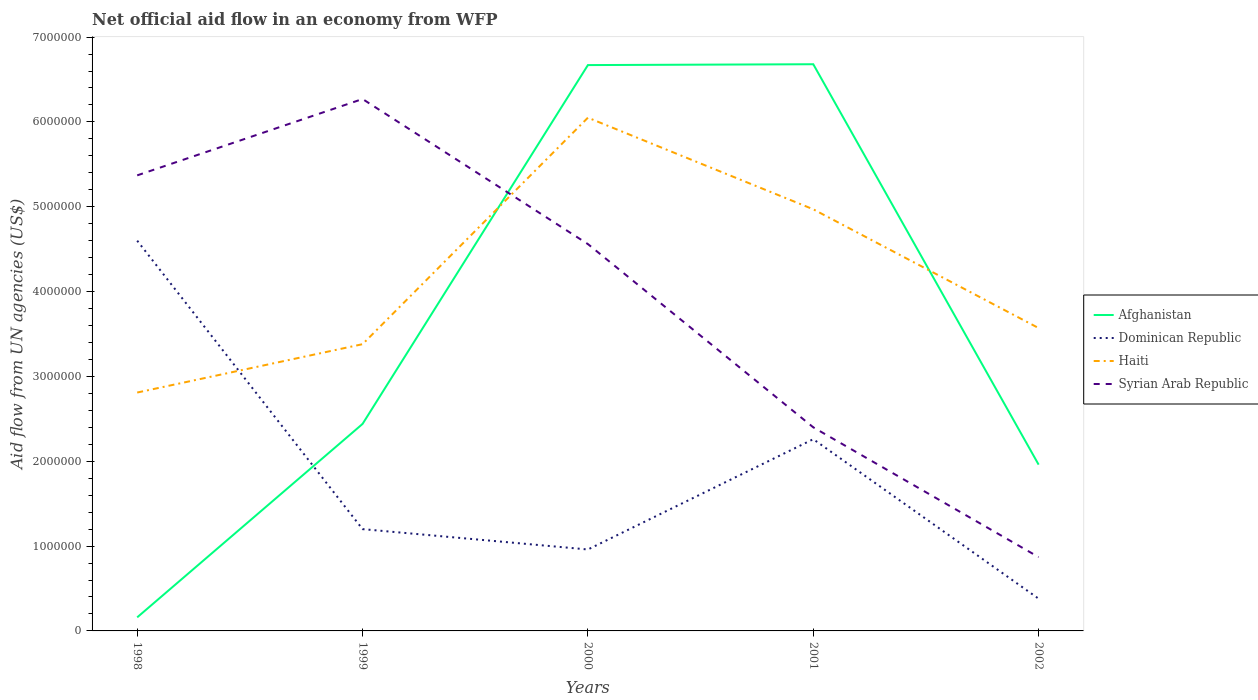How many different coloured lines are there?
Provide a succinct answer. 4. Does the line corresponding to Syrian Arab Republic intersect with the line corresponding to Afghanistan?
Provide a succinct answer. Yes. Across all years, what is the maximum net official aid flow in Dominican Republic?
Your answer should be very brief. 3.80e+05. In which year was the net official aid flow in Syrian Arab Republic maximum?
Your answer should be compact. 2002. What is the total net official aid flow in Dominican Republic in the graph?
Keep it short and to the point. 5.80e+05. What is the difference between the highest and the second highest net official aid flow in Afghanistan?
Your answer should be very brief. 6.52e+06. How many years are there in the graph?
Make the answer very short. 5. Are the values on the major ticks of Y-axis written in scientific E-notation?
Make the answer very short. No. Does the graph contain any zero values?
Your response must be concise. No. How many legend labels are there?
Provide a succinct answer. 4. How are the legend labels stacked?
Your answer should be compact. Vertical. What is the title of the graph?
Ensure brevity in your answer.  Net official aid flow in an economy from WFP. Does "Benin" appear as one of the legend labels in the graph?
Your answer should be very brief. No. What is the label or title of the X-axis?
Your answer should be very brief. Years. What is the label or title of the Y-axis?
Provide a succinct answer. Aid flow from UN agencies (US$). What is the Aid flow from UN agencies (US$) in Dominican Republic in 1998?
Ensure brevity in your answer.  4.60e+06. What is the Aid flow from UN agencies (US$) of Haiti in 1998?
Your response must be concise. 2.81e+06. What is the Aid flow from UN agencies (US$) of Syrian Arab Republic in 1998?
Provide a succinct answer. 5.37e+06. What is the Aid flow from UN agencies (US$) of Afghanistan in 1999?
Provide a succinct answer. 2.44e+06. What is the Aid flow from UN agencies (US$) of Dominican Republic in 1999?
Your response must be concise. 1.20e+06. What is the Aid flow from UN agencies (US$) in Haiti in 1999?
Provide a short and direct response. 3.38e+06. What is the Aid flow from UN agencies (US$) of Syrian Arab Republic in 1999?
Make the answer very short. 6.27e+06. What is the Aid flow from UN agencies (US$) in Afghanistan in 2000?
Your answer should be very brief. 6.67e+06. What is the Aid flow from UN agencies (US$) in Dominican Republic in 2000?
Keep it short and to the point. 9.60e+05. What is the Aid flow from UN agencies (US$) in Haiti in 2000?
Your answer should be compact. 6.05e+06. What is the Aid flow from UN agencies (US$) of Syrian Arab Republic in 2000?
Offer a terse response. 4.56e+06. What is the Aid flow from UN agencies (US$) in Afghanistan in 2001?
Your response must be concise. 6.68e+06. What is the Aid flow from UN agencies (US$) in Dominican Republic in 2001?
Provide a short and direct response. 2.26e+06. What is the Aid flow from UN agencies (US$) in Haiti in 2001?
Give a very brief answer. 4.97e+06. What is the Aid flow from UN agencies (US$) of Syrian Arab Republic in 2001?
Ensure brevity in your answer.  2.40e+06. What is the Aid flow from UN agencies (US$) in Afghanistan in 2002?
Provide a short and direct response. 1.96e+06. What is the Aid flow from UN agencies (US$) in Dominican Republic in 2002?
Ensure brevity in your answer.  3.80e+05. What is the Aid flow from UN agencies (US$) of Haiti in 2002?
Provide a short and direct response. 3.57e+06. What is the Aid flow from UN agencies (US$) in Syrian Arab Republic in 2002?
Offer a terse response. 8.70e+05. Across all years, what is the maximum Aid flow from UN agencies (US$) of Afghanistan?
Give a very brief answer. 6.68e+06. Across all years, what is the maximum Aid flow from UN agencies (US$) in Dominican Republic?
Provide a succinct answer. 4.60e+06. Across all years, what is the maximum Aid flow from UN agencies (US$) of Haiti?
Give a very brief answer. 6.05e+06. Across all years, what is the maximum Aid flow from UN agencies (US$) of Syrian Arab Republic?
Ensure brevity in your answer.  6.27e+06. Across all years, what is the minimum Aid flow from UN agencies (US$) of Dominican Republic?
Give a very brief answer. 3.80e+05. Across all years, what is the minimum Aid flow from UN agencies (US$) of Haiti?
Your response must be concise. 2.81e+06. Across all years, what is the minimum Aid flow from UN agencies (US$) of Syrian Arab Republic?
Your response must be concise. 8.70e+05. What is the total Aid flow from UN agencies (US$) of Afghanistan in the graph?
Your answer should be compact. 1.79e+07. What is the total Aid flow from UN agencies (US$) in Dominican Republic in the graph?
Provide a short and direct response. 9.40e+06. What is the total Aid flow from UN agencies (US$) in Haiti in the graph?
Give a very brief answer. 2.08e+07. What is the total Aid flow from UN agencies (US$) of Syrian Arab Republic in the graph?
Keep it short and to the point. 1.95e+07. What is the difference between the Aid flow from UN agencies (US$) of Afghanistan in 1998 and that in 1999?
Provide a short and direct response. -2.28e+06. What is the difference between the Aid flow from UN agencies (US$) of Dominican Republic in 1998 and that in 1999?
Ensure brevity in your answer.  3.40e+06. What is the difference between the Aid flow from UN agencies (US$) of Haiti in 1998 and that in 1999?
Your answer should be compact. -5.70e+05. What is the difference between the Aid flow from UN agencies (US$) of Syrian Arab Republic in 1998 and that in 1999?
Offer a very short reply. -9.00e+05. What is the difference between the Aid flow from UN agencies (US$) of Afghanistan in 1998 and that in 2000?
Your response must be concise. -6.51e+06. What is the difference between the Aid flow from UN agencies (US$) in Dominican Republic in 1998 and that in 2000?
Your answer should be compact. 3.64e+06. What is the difference between the Aid flow from UN agencies (US$) of Haiti in 1998 and that in 2000?
Your answer should be very brief. -3.24e+06. What is the difference between the Aid flow from UN agencies (US$) in Syrian Arab Republic in 1998 and that in 2000?
Keep it short and to the point. 8.10e+05. What is the difference between the Aid flow from UN agencies (US$) in Afghanistan in 1998 and that in 2001?
Provide a succinct answer. -6.52e+06. What is the difference between the Aid flow from UN agencies (US$) of Dominican Republic in 1998 and that in 2001?
Give a very brief answer. 2.34e+06. What is the difference between the Aid flow from UN agencies (US$) in Haiti in 1998 and that in 2001?
Your answer should be very brief. -2.16e+06. What is the difference between the Aid flow from UN agencies (US$) in Syrian Arab Republic in 1998 and that in 2001?
Your answer should be compact. 2.97e+06. What is the difference between the Aid flow from UN agencies (US$) in Afghanistan in 1998 and that in 2002?
Your response must be concise. -1.80e+06. What is the difference between the Aid flow from UN agencies (US$) in Dominican Republic in 1998 and that in 2002?
Provide a short and direct response. 4.22e+06. What is the difference between the Aid flow from UN agencies (US$) of Haiti in 1998 and that in 2002?
Give a very brief answer. -7.60e+05. What is the difference between the Aid flow from UN agencies (US$) of Syrian Arab Republic in 1998 and that in 2002?
Ensure brevity in your answer.  4.50e+06. What is the difference between the Aid flow from UN agencies (US$) of Afghanistan in 1999 and that in 2000?
Make the answer very short. -4.23e+06. What is the difference between the Aid flow from UN agencies (US$) of Haiti in 1999 and that in 2000?
Your answer should be compact. -2.67e+06. What is the difference between the Aid flow from UN agencies (US$) of Syrian Arab Republic in 1999 and that in 2000?
Make the answer very short. 1.71e+06. What is the difference between the Aid flow from UN agencies (US$) of Afghanistan in 1999 and that in 2001?
Your answer should be very brief. -4.24e+06. What is the difference between the Aid flow from UN agencies (US$) of Dominican Republic in 1999 and that in 2001?
Your response must be concise. -1.06e+06. What is the difference between the Aid flow from UN agencies (US$) in Haiti in 1999 and that in 2001?
Your answer should be compact. -1.59e+06. What is the difference between the Aid flow from UN agencies (US$) of Syrian Arab Republic in 1999 and that in 2001?
Keep it short and to the point. 3.87e+06. What is the difference between the Aid flow from UN agencies (US$) of Afghanistan in 1999 and that in 2002?
Provide a short and direct response. 4.80e+05. What is the difference between the Aid flow from UN agencies (US$) in Dominican Republic in 1999 and that in 2002?
Ensure brevity in your answer.  8.20e+05. What is the difference between the Aid flow from UN agencies (US$) in Syrian Arab Republic in 1999 and that in 2002?
Give a very brief answer. 5.40e+06. What is the difference between the Aid flow from UN agencies (US$) in Dominican Republic in 2000 and that in 2001?
Provide a short and direct response. -1.30e+06. What is the difference between the Aid flow from UN agencies (US$) of Haiti in 2000 and that in 2001?
Ensure brevity in your answer.  1.08e+06. What is the difference between the Aid flow from UN agencies (US$) in Syrian Arab Republic in 2000 and that in 2001?
Give a very brief answer. 2.16e+06. What is the difference between the Aid flow from UN agencies (US$) of Afghanistan in 2000 and that in 2002?
Your response must be concise. 4.71e+06. What is the difference between the Aid flow from UN agencies (US$) in Dominican Republic in 2000 and that in 2002?
Provide a succinct answer. 5.80e+05. What is the difference between the Aid flow from UN agencies (US$) of Haiti in 2000 and that in 2002?
Your response must be concise. 2.48e+06. What is the difference between the Aid flow from UN agencies (US$) of Syrian Arab Republic in 2000 and that in 2002?
Make the answer very short. 3.69e+06. What is the difference between the Aid flow from UN agencies (US$) of Afghanistan in 2001 and that in 2002?
Give a very brief answer. 4.72e+06. What is the difference between the Aid flow from UN agencies (US$) of Dominican Republic in 2001 and that in 2002?
Offer a terse response. 1.88e+06. What is the difference between the Aid flow from UN agencies (US$) of Haiti in 2001 and that in 2002?
Your answer should be very brief. 1.40e+06. What is the difference between the Aid flow from UN agencies (US$) in Syrian Arab Republic in 2001 and that in 2002?
Your answer should be very brief. 1.53e+06. What is the difference between the Aid flow from UN agencies (US$) in Afghanistan in 1998 and the Aid flow from UN agencies (US$) in Dominican Republic in 1999?
Your answer should be very brief. -1.04e+06. What is the difference between the Aid flow from UN agencies (US$) of Afghanistan in 1998 and the Aid flow from UN agencies (US$) of Haiti in 1999?
Provide a succinct answer. -3.22e+06. What is the difference between the Aid flow from UN agencies (US$) of Afghanistan in 1998 and the Aid flow from UN agencies (US$) of Syrian Arab Republic in 1999?
Give a very brief answer. -6.11e+06. What is the difference between the Aid flow from UN agencies (US$) of Dominican Republic in 1998 and the Aid flow from UN agencies (US$) of Haiti in 1999?
Offer a terse response. 1.22e+06. What is the difference between the Aid flow from UN agencies (US$) in Dominican Republic in 1998 and the Aid flow from UN agencies (US$) in Syrian Arab Republic in 1999?
Give a very brief answer. -1.67e+06. What is the difference between the Aid flow from UN agencies (US$) of Haiti in 1998 and the Aid flow from UN agencies (US$) of Syrian Arab Republic in 1999?
Your answer should be compact. -3.46e+06. What is the difference between the Aid flow from UN agencies (US$) in Afghanistan in 1998 and the Aid flow from UN agencies (US$) in Dominican Republic in 2000?
Give a very brief answer. -8.00e+05. What is the difference between the Aid flow from UN agencies (US$) in Afghanistan in 1998 and the Aid flow from UN agencies (US$) in Haiti in 2000?
Provide a short and direct response. -5.89e+06. What is the difference between the Aid flow from UN agencies (US$) of Afghanistan in 1998 and the Aid flow from UN agencies (US$) of Syrian Arab Republic in 2000?
Offer a terse response. -4.40e+06. What is the difference between the Aid flow from UN agencies (US$) in Dominican Republic in 1998 and the Aid flow from UN agencies (US$) in Haiti in 2000?
Ensure brevity in your answer.  -1.45e+06. What is the difference between the Aid flow from UN agencies (US$) of Haiti in 1998 and the Aid flow from UN agencies (US$) of Syrian Arab Republic in 2000?
Offer a terse response. -1.75e+06. What is the difference between the Aid flow from UN agencies (US$) in Afghanistan in 1998 and the Aid flow from UN agencies (US$) in Dominican Republic in 2001?
Provide a succinct answer. -2.10e+06. What is the difference between the Aid flow from UN agencies (US$) of Afghanistan in 1998 and the Aid flow from UN agencies (US$) of Haiti in 2001?
Ensure brevity in your answer.  -4.81e+06. What is the difference between the Aid flow from UN agencies (US$) in Afghanistan in 1998 and the Aid flow from UN agencies (US$) in Syrian Arab Republic in 2001?
Offer a terse response. -2.24e+06. What is the difference between the Aid flow from UN agencies (US$) in Dominican Republic in 1998 and the Aid flow from UN agencies (US$) in Haiti in 2001?
Your answer should be compact. -3.70e+05. What is the difference between the Aid flow from UN agencies (US$) in Dominican Republic in 1998 and the Aid flow from UN agencies (US$) in Syrian Arab Republic in 2001?
Your answer should be very brief. 2.20e+06. What is the difference between the Aid flow from UN agencies (US$) of Afghanistan in 1998 and the Aid flow from UN agencies (US$) of Haiti in 2002?
Ensure brevity in your answer.  -3.41e+06. What is the difference between the Aid flow from UN agencies (US$) of Afghanistan in 1998 and the Aid flow from UN agencies (US$) of Syrian Arab Republic in 2002?
Ensure brevity in your answer.  -7.10e+05. What is the difference between the Aid flow from UN agencies (US$) of Dominican Republic in 1998 and the Aid flow from UN agencies (US$) of Haiti in 2002?
Provide a succinct answer. 1.03e+06. What is the difference between the Aid flow from UN agencies (US$) of Dominican Republic in 1998 and the Aid flow from UN agencies (US$) of Syrian Arab Republic in 2002?
Provide a succinct answer. 3.73e+06. What is the difference between the Aid flow from UN agencies (US$) in Haiti in 1998 and the Aid flow from UN agencies (US$) in Syrian Arab Republic in 2002?
Ensure brevity in your answer.  1.94e+06. What is the difference between the Aid flow from UN agencies (US$) of Afghanistan in 1999 and the Aid flow from UN agencies (US$) of Dominican Republic in 2000?
Offer a very short reply. 1.48e+06. What is the difference between the Aid flow from UN agencies (US$) of Afghanistan in 1999 and the Aid flow from UN agencies (US$) of Haiti in 2000?
Offer a very short reply. -3.61e+06. What is the difference between the Aid flow from UN agencies (US$) of Afghanistan in 1999 and the Aid flow from UN agencies (US$) of Syrian Arab Republic in 2000?
Make the answer very short. -2.12e+06. What is the difference between the Aid flow from UN agencies (US$) in Dominican Republic in 1999 and the Aid flow from UN agencies (US$) in Haiti in 2000?
Offer a very short reply. -4.85e+06. What is the difference between the Aid flow from UN agencies (US$) of Dominican Republic in 1999 and the Aid flow from UN agencies (US$) of Syrian Arab Republic in 2000?
Your response must be concise. -3.36e+06. What is the difference between the Aid flow from UN agencies (US$) of Haiti in 1999 and the Aid flow from UN agencies (US$) of Syrian Arab Republic in 2000?
Make the answer very short. -1.18e+06. What is the difference between the Aid flow from UN agencies (US$) of Afghanistan in 1999 and the Aid flow from UN agencies (US$) of Dominican Republic in 2001?
Provide a short and direct response. 1.80e+05. What is the difference between the Aid flow from UN agencies (US$) of Afghanistan in 1999 and the Aid flow from UN agencies (US$) of Haiti in 2001?
Give a very brief answer. -2.53e+06. What is the difference between the Aid flow from UN agencies (US$) of Afghanistan in 1999 and the Aid flow from UN agencies (US$) of Syrian Arab Republic in 2001?
Your answer should be compact. 4.00e+04. What is the difference between the Aid flow from UN agencies (US$) in Dominican Republic in 1999 and the Aid flow from UN agencies (US$) in Haiti in 2001?
Offer a very short reply. -3.77e+06. What is the difference between the Aid flow from UN agencies (US$) of Dominican Republic in 1999 and the Aid flow from UN agencies (US$) of Syrian Arab Republic in 2001?
Ensure brevity in your answer.  -1.20e+06. What is the difference between the Aid flow from UN agencies (US$) of Haiti in 1999 and the Aid flow from UN agencies (US$) of Syrian Arab Republic in 2001?
Your response must be concise. 9.80e+05. What is the difference between the Aid flow from UN agencies (US$) of Afghanistan in 1999 and the Aid flow from UN agencies (US$) of Dominican Republic in 2002?
Make the answer very short. 2.06e+06. What is the difference between the Aid flow from UN agencies (US$) in Afghanistan in 1999 and the Aid flow from UN agencies (US$) in Haiti in 2002?
Your answer should be compact. -1.13e+06. What is the difference between the Aid flow from UN agencies (US$) in Afghanistan in 1999 and the Aid flow from UN agencies (US$) in Syrian Arab Republic in 2002?
Provide a short and direct response. 1.57e+06. What is the difference between the Aid flow from UN agencies (US$) in Dominican Republic in 1999 and the Aid flow from UN agencies (US$) in Haiti in 2002?
Make the answer very short. -2.37e+06. What is the difference between the Aid flow from UN agencies (US$) in Dominican Republic in 1999 and the Aid flow from UN agencies (US$) in Syrian Arab Republic in 2002?
Offer a terse response. 3.30e+05. What is the difference between the Aid flow from UN agencies (US$) of Haiti in 1999 and the Aid flow from UN agencies (US$) of Syrian Arab Republic in 2002?
Provide a succinct answer. 2.51e+06. What is the difference between the Aid flow from UN agencies (US$) in Afghanistan in 2000 and the Aid flow from UN agencies (US$) in Dominican Republic in 2001?
Ensure brevity in your answer.  4.41e+06. What is the difference between the Aid flow from UN agencies (US$) of Afghanistan in 2000 and the Aid flow from UN agencies (US$) of Haiti in 2001?
Your response must be concise. 1.70e+06. What is the difference between the Aid flow from UN agencies (US$) of Afghanistan in 2000 and the Aid flow from UN agencies (US$) of Syrian Arab Republic in 2001?
Offer a terse response. 4.27e+06. What is the difference between the Aid flow from UN agencies (US$) of Dominican Republic in 2000 and the Aid flow from UN agencies (US$) of Haiti in 2001?
Provide a short and direct response. -4.01e+06. What is the difference between the Aid flow from UN agencies (US$) in Dominican Republic in 2000 and the Aid flow from UN agencies (US$) in Syrian Arab Republic in 2001?
Your response must be concise. -1.44e+06. What is the difference between the Aid flow from UN agencies (US$) of Haiti in 2000 and the Aid flow from UN agencies (US$) of Syrian Arab Republic in 2001?
Your response must be concise. 3.65e+06. What is the difference between the Aid flow from UN agencies (US$) in Afghanistan in 2000 and the Aid flow from UN agencies (US$) in Dominican Republic in 2002?
Provide a short and direct response. 6.29e+06. What is the difference between the Aid flow from UN agencies (US$) of Afghanistan in 2000 and the Aid flow from UN agencies (US$) of Haiti in 2002?
Keep it short and to the point. 3.10e+06. What is the difference between the Aid flow from UN agencies (US$) of Afghanistan in 2000 and the Aid flow from UN agencies (US$) of Syrian Arab Republic in 2002?
Provide a succinct answer. 5.80e+06. What is the difference between the Aid flow from UN agencies (US$) of Dominican Republic in 2000 and the Aid flow from UN agencies (US$) of Haiti in 2002?
Your answer should be very brief. -2.61e+06. What is the difference between the Aid flow from UN agencies (US$) of Dominican Republic in 2000 and the Aid flow from UN agencies (US$) of Syrian Arab Republic in 2002?
Offer a terse response. 9.00e+04. What is the difference between the Aid flow from UN agencies (US$) of Haiti in 2000 and the Aid flow from UN agencies (US$) of Syrian Arab Republic in 2002?
Keep it short and to the point. 5.18e+06. What is the difference between the Aid flow from UN agencies (US$) of Afghanistan in 2001 and the Aid flow from UN agencies (US$) of Dominican Republic in 2002?
Give a very brief answer. 6.30e+06. What is the difference between the Aid flow from UN agencies (US$) of Afghanistan in 2001 and the Aid flow from UN agencies (US$) of Haiti in 2002?
Your response must be concise. 3.11e+06. What is the difference between the Aid flow from UN agencies (US$) in Afghanistan in 2001 and the Aid flow from UN agencies (US$) in Syrian Arab Republic in 2002?
Make the answer very short. 5.81e+06. What is the difference between the Aid flow from UN agencies (US$) of Dominican Republic in 2001 and the Aid flow from UN agencies (US$) of Haiti in 2002?
Offer a terse response. -1.31e+06. What is the difference between the Aid flow from UN agencies (US$) of Dominican Republic in 2001 and the Aid flow from UN agencies (US$) of Syrian Arab Republic in 2002?
Offer a terse response. 1.39e+06. What is the difference between the Aid flow from UN agencies (US$) in Haiti in 2001 and the Aid flow from UN agencies (US$) in Syrian Arab Republic in 2002?
Give a very brief answer. 4.10e+06. What is the average Aid flow from UN agencies (US$) of Afghanistan per year?
Ensure brevity in your answer.  3.58e+06. What is the average Aid flow from UN agencies (US$) of Dominican Republic per year?
Offer a very short reply. 1.88e+06. What is the average Aid flow from UN agencies (US$) of Haiti per year?
Your response must be concise. 4.16e+06. What is the average Aid flow from UN agencies (US$) of Syrian Arab Republic per year?
Make the answer very short. 3.89e+06. In the year 1998, what is the difference between the Aid flow from UN agencies (US$) in Afghanistan and Aid flow from UN agencies (US$) in Dominican Republic?
Your answer should be compact. -4.44e+06. In the year 1998, what is the difference between the Aid flow from UN agencies (US$) of Afghanistan and Aid flow from UN agencies (US$) of Haiti?
Ensure brevity in your answer.  -2.65e+06. In the year 1998, what is the difference between the Aid flow from UN agencies (US$) of Afghanistan and Aid flow from UN agencies (US$) of Syrian Arab Republic?
Offer a terse response. -5.21e+06. In the year 1998, what is the difference between the Aid flow from UN agencies (US$) in Dominican Republic and Aid flow from UN agencies (US$) in Haiti?
Offer a very short reply. 1.79e+06. In the year 1998, what is the difference between the Aid flow from UN agencies (US$) in Dominican Republic and Aid flow from UN agencies (US$) in Syrian Arab Republic?
Make the answer very short. -7.70e+05. In the year 1998, what is the difference between the Aid flow from UN agencies (US$) in Haiti and Aid flow from UN agencies (US$) in Syrian Arab Republic?
Your answer should be very brief. -2.56e+06. In the year 1999, what is the difference between the Aid flow from UN agencies (US$) in Afghanistan and Aid flow from UN agencies (US$) in Dominican Republic?
Offer a very short reply. 1.24e+06. In the year 1999, what is the difference between the Aid flow from UN agencies (US$) in Afghanistan and Aid flow from UN agencies (US$) in Haiti?
Provide a short and direct response. -9.40e+05. In the year 1999, what is the difference between the Aid flow from UN agencies (US$) of Afghanistan and Aid flow from UN agencies (US$) of Syrian Arab Republic?
Offer a very short reply. -3.83e+06. In the year 1999, what is the difference between the Aid flow from UN agencies (US$) of Dominican Republic and Aid flow from UN agencies (US$) of Haiti?
Provide a succinct answer. -2.18e+06. In the year 1999, what is the difference between the Aid flow from UN agencies (US$) of Dominican Republic and Aid flow from UN agencies (US$) of Syrian Arab Republic?
Keep it short and to the point. -5.07e+06. In the year 1999, what is the difference between the Aid flow from UN agencies (US$) of Haiti and Aid flow from UN agencies (US$) of Syrian Arab Republic?
Keep it short and to the point. -2.89e+06. In the year 2000, what is the difference between the Aid flow from UN agencies (US$) in Afghanistan and Aid flow from UN agencies (US$) in Dominican Republic?
Keep it short and to the point. 5.71e+06. In the year 2000, what is the difference between the Aid flow from UN agencies (US$) in Afghanistan and Aid flow from UN agencies (US$) in Haiti?
Ensure brevity in your answer.  6.20e+05. In the year 2000, what is the difference between the Aid flow from UN agencies (US$) of Afghanistan and Aid flow from UN agencies (US$) of Syrian Arab Republic?
Ensure brevity in your answer.  2.11e+06. In the year 2000, what is the difference between the Aid flow from UN agencies (US$) in Dominican Republic and Aid flow from UN agencies (US$) in Haiti?
Offer a very short reply. -5.09e+06. In the year 2000, what is the difference between the Aid flow from UN agencies (US$) of Dominican Republic and Aid flow from UN agencies (US$) of Syrian Arab Republic?
Offer a very short reply. -3.60e+06. In the year 2000, what is the difference between the Aid flow from UN agencies (US$) of Haiti and Aid flow from UN agencies (US$) of Syrian Arab Republic?
Your answer should be compact. 1.49e+06. In the year 2001, what is the difference between the Aid flow from UN agencies (US$) of Afghanistan and Aid flow from UN agencies (US$) of Dominican Republic?
Your response must be concise. 4.42e+06. In the year 2001, what is the difference between the Aid flow from UN agencies (US$) in Afghanistan and Aid flow from UN agencies (US$) in Haiti?
Give a very brief answer. 1.71e+06. In the year 2001, what is the difference between the Aid flow from UN agencies (US$) of Afghanistan and Aid flow from UN agencies (US$) of Syrian Arab Republic?
Give a very brief answer. 4.28e+06. In the year 2001, what is the difference between the Aid flow from UN agencies (US$) of Dominican Republic and Aid flow from UN agencies (US$) of Haiti?
Give a very brief answer. -2.71e+06. In the year 2001, what is the difference between the Aid flow from UN agencies (US$) in Haiti and Aid flow from UN agencies (US$) in Syrian Arab Republic?
Provide a succinct answer. 2.57e+06. In the year 2002, what is the difference between the Aid flow from UN agencies (US$) of Afghanistan and Aid flow from UN agencies (US$) of Dominican Republic?
Offer a very short reply. 1.58e+06. In the year 2002, what is the difference between the Aid flow from UN agencies (US$) in Afghanistan and Aid flow from UN agencies (US$) in Haiti?
Keep it short and to the point. -1.61e+06. In the year 2002, what is the difference between the Aid flow from UN agencies (US$) of Afghanistan and Aid flow from UN agencies (US$) of Syrian Arab Republic?
Your answer should be very brief. 1.09e+06. In the year 2002, what is the difference between the Aid flow from UN agencies (US$) of Dominican Republic and Aid flow from UN agencies (US$) of Haiti?
Provide a succinct answer. -3.19e+06. In the year 2002, what is the difference between the Aid flow from UN agencies (US$) in Dominican Republic and Aid flow from UN agencies (US$) in Syrian Arab Republic?
Offer a very short reply. -4.90e+05. In the year 2002, what is the difference between the Aid flow from UN agencies (US$) in Haiti and Aid flow from UN agencies (US$) in Syrian Arab Republic?
Ensure brevity in your answer.  2.70e+06. What is the ratio of the Aid flow from UN agencies (US$) of Afghanistan in 1998 to that in 1999?
Provide a succinct answer. 0.07. What is the ratio of the Aid flow from UN agencies (US$) in Dominican Republic in 1998 to that in 1999?
Provide a short and direct response. 3.83. What is the ratio of the Aid flow from UN agencies (US$) of Haiti in 1998 to that in 1999?
Your answer should be very brief. 0.83. What is the ratio of the Aid flow from UN agencies (US$) in Syrian Arab Republic in 1998 to that in 1999?
Your answer should be very brief. 0.86. What is the ratio of the Aid flow from UN agencies (US$) in Afghanistan in 1998 to that in 2000?
Your answer should be compact. 0.02. What is the ratio of the Aid flow from UN agencies (US$) of Dominican Republic in 1998 to that in 2000?
Offer a very short reply. 4.79. What is the ratio of the Aid flow from UN agencies (US$) in Haiti in 1998 to that in 2000?
Ensure brevity in your answer.  0.46. What is the ratio of the Aid flow from UN agencies (US$) of Syrian Arab Republic in 1998 to that in 2000?
Provide a succinct answer. 1.18. What is the ratio of the Aid flow from UN agencies (US$) in Afghanistan in 1998 to that in 2001?
Provide a short and direct response. 0.02. What is the ratio of the Aid flow from UN agencies (US$) in Dominican Republic in 1998 to that in 2001?
Make the answer very short. 2.04. What is the ratio of the Aid flow from UN agencies (US$) in Haiti in 1998 to that in 2001?
Your answer should be very brief. 0.57. What is the ratio of the Aid flow from UN agencies (US$) of Syrian Arab Republic in 1998 to that in 2001?
Provide a succinct answer. 2.24. What is the ratio of the Aid flow from UN agencies (US$) of Afghanistan in 1998 to that in 2002?
Offer a terse response. 0.08. What is the ratio of the Aid flow from UN agencies (US$) in Dominican Republic in 1998 to that in 2002?
Offer a very short reply. 12.11. What is the ratio of the Aid flow from UN agencies (US$) in Haiti in 1998 to that in 2002?
Offer a terse response. 0.79. What is the ratio of the Aid flow from UN agencies (US$) in Syrian Arab Republic in 1998 to that in 2002?
Provide a short and direct response. 6.17. What is the ratio of the Aid flow from UN agencies (US$) of Afghanistan in 1999 to that in 2000?
Your answer should be very brief. 0.37. What is the ratio of the Aid flow from UN agencies (US$) of Haiti in 1999 to that in 2000?
Make the answer very short. 0.56. What is the ratio of the Aid flow from UN agencies (US$) in Syrian Arab Republic in 1999 to that in 2000?
Give a very brief answer. 1.38. What is the ratio of the Aid flow from UN agencies (US$) of Afghanistan in 1999 to that in 2001?
Make the answer very short. 0.37. What is the ratio of the Aid flow from UN agencies (US$) of Dominican Republic in 1999 to that in 2001?
Ensure brevity in your answer.  0.53. What is the ratio of the Aid flow from UN agencies (US$) of Haiti in 1999 to that in 2001?
Your answer should be compact. 0.68. What is the ratio of the Aid flow from UN agencies (US$) of Syrian Arab Republic in 1999 to that in 2001?
Ensure brevity in your answer.  2.61. What is the ratio of the Aid flow from UN agencies (US$) in Afghanistan in 1999 to that in 2002?
Your answer should be compact. 1.24. What is the ratio of the Aid flow from UN agencies (US$) of Dominican Republic in 1999 to that in 2002?
Offer a very short reply. 3.16. What is the ratio of the Aid flow from UN agencies (US$) in Haiti in 1999 to that in 2002?
Offer a terse response. 0.95. What is the ratio of the Aid flow from UN agencies (US$) in Syrian Arab Republic in 1999 to that in 2002?
Make the answer very short. 7.21. What is the ratio of the Aid flow from UN agencies (US$) in Afghanistan in 2000 to that in 2001?
Give a very brief answer. 1. What is the ratio of the Aid flow from UN agencies (US$) in Dominican Republic in 2000 to that in 2001?
Provide a short and direct response. 0.42. What is the ratio of the Aid flow from UN agencies (US$) of Haiti in 2000 to that in 2001?
Ensure brevity in your answer.  1.22. What is the ratio of the Aid flow from UN agencies (US$) of Afghanistan in 2000 to that in 2002?
Offer a terse response. 3.4. What is the ratio of the Aid flow from UN agencies (US$) of Dominican Republic in 2000 to that in 2002?
Make the answer very short. 2.53. What is the ratio of the Aid flow from UN agencies (US$) of Haiti in 2000 to that in 2002?
Provide a succinct answer. 1.69. What is the ratio of the Aid flow from UN agencies (US$) in Syrian Arab Republic in 2000 to that in 2002?
Offer a very short reply. 5.24. What is the ratio of the Aid flow from UN agencies (US$) of Afghanistan in 2001 to that in 2002?
Provide a short and direct response. 3.41. What is the ratio of the Aid flow from UN agencies (US$) of Dominican Republic in 2001 to that in 2002?
Your answer should be compact. 5.95. What is the ratio of the Aid flow from UN agencies (US$) of Haiti in 2001 to that in 2002?
Your answer should be very brief. 1.39. What is the ratio of the Aid flow from UN agencies (US$) of Syrian Arab Republic in 2001 to that in 2002?
Make the answer very short. 2.76. What is the difference between the highest and the second highest Aid flow from UN agencies (US$) in Afghanistan?
Offer a terse response. 10000. What is the difference between the highest and the second highest Aid flow from UN agencies (US$) of Dominican Republic?
Your answer should be very brief. 2.34e+06. What is the difference between the highest and the second highest Aid flow from UN agencies (US$) in Haiti?
Offer a terse response. 1.08e+06. What is the difference between the highest and the lowest Aid flow from UN agencies (US$) of Afghanistan?
Keep it short and to the point. 6.52e+06. What is the difference between the highest and the lowest Aid flow from UN agencies (US$) in Dominican Republic?
Your answer should be very brief. 4.22e+06. What is the difference between the highest and the lowest Aid flow from UN agencies (US$) in Haiti?
Your response must be concise. 3.24e+06. What is the difference between the highest and the lowest Aid flow from UN agencies (US$) in Syrian Arab Republic?
Offer a very short reply. 5.40e+06. 